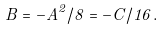Convert formula to latex. <formula><loc_0><loc_0><loc_500><loc_500>B = - A ^ { 2 } / 8 = - C / 1 6 .</formula> 